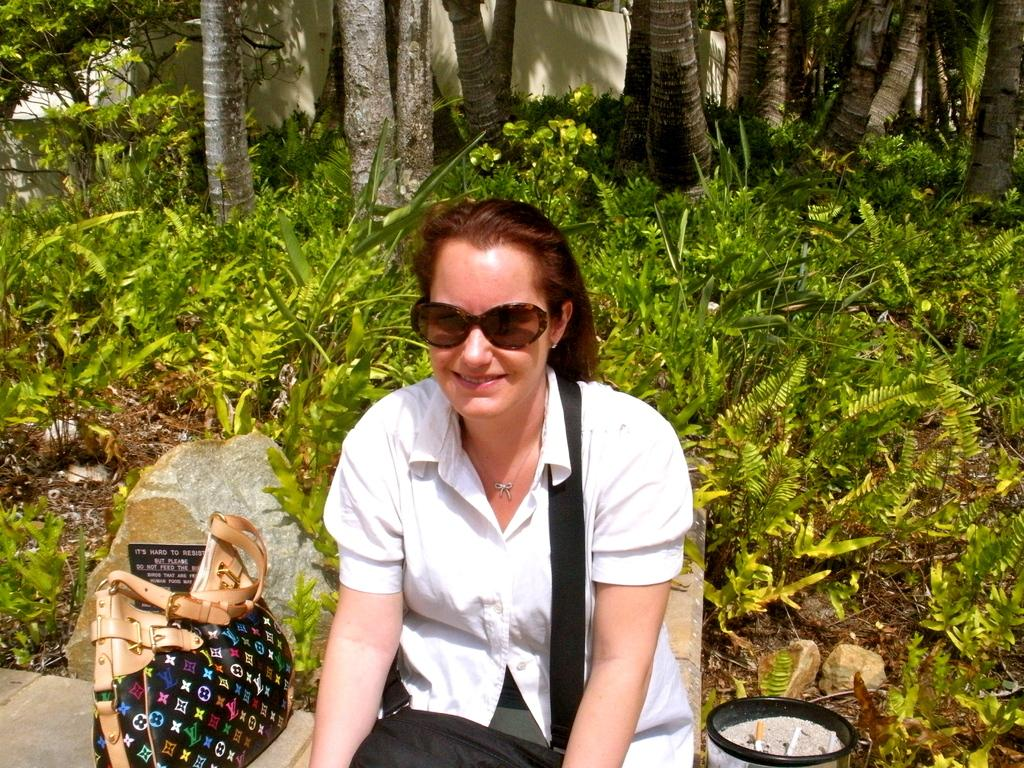What is the main subject in the foreground of the image? There is a woman sitting in the foreground of the image. What object is beside the woman? There is a bag beside the woman. What type of natural elements can be seen in the background of the image? There are plants and trees in the background of the image. What type of man-made structure is visible in the background of the image? There is a wall in the background of the image. How many notebooks are stacked on the plastic bikes in the image? There are no notebooks or plastic bikes present in the image. 